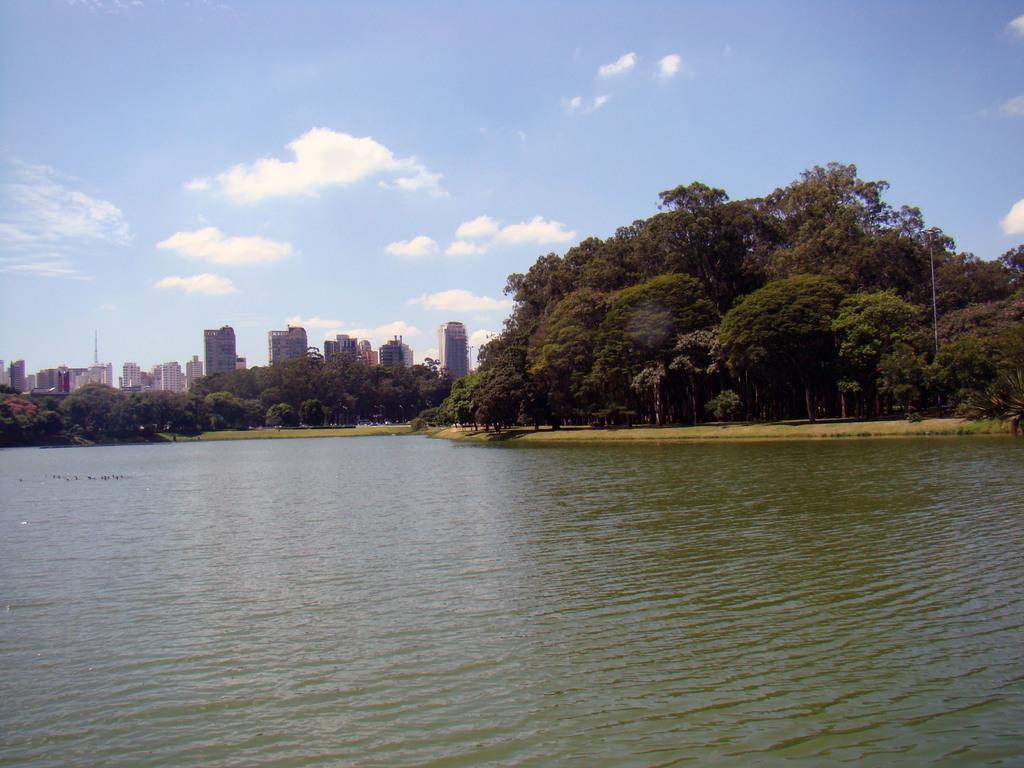Describe this image in one or two sentences. In this picture I can see the water in front and in the center of this picture I can see number of trees and buildings. In the background I can see the clear sky. 